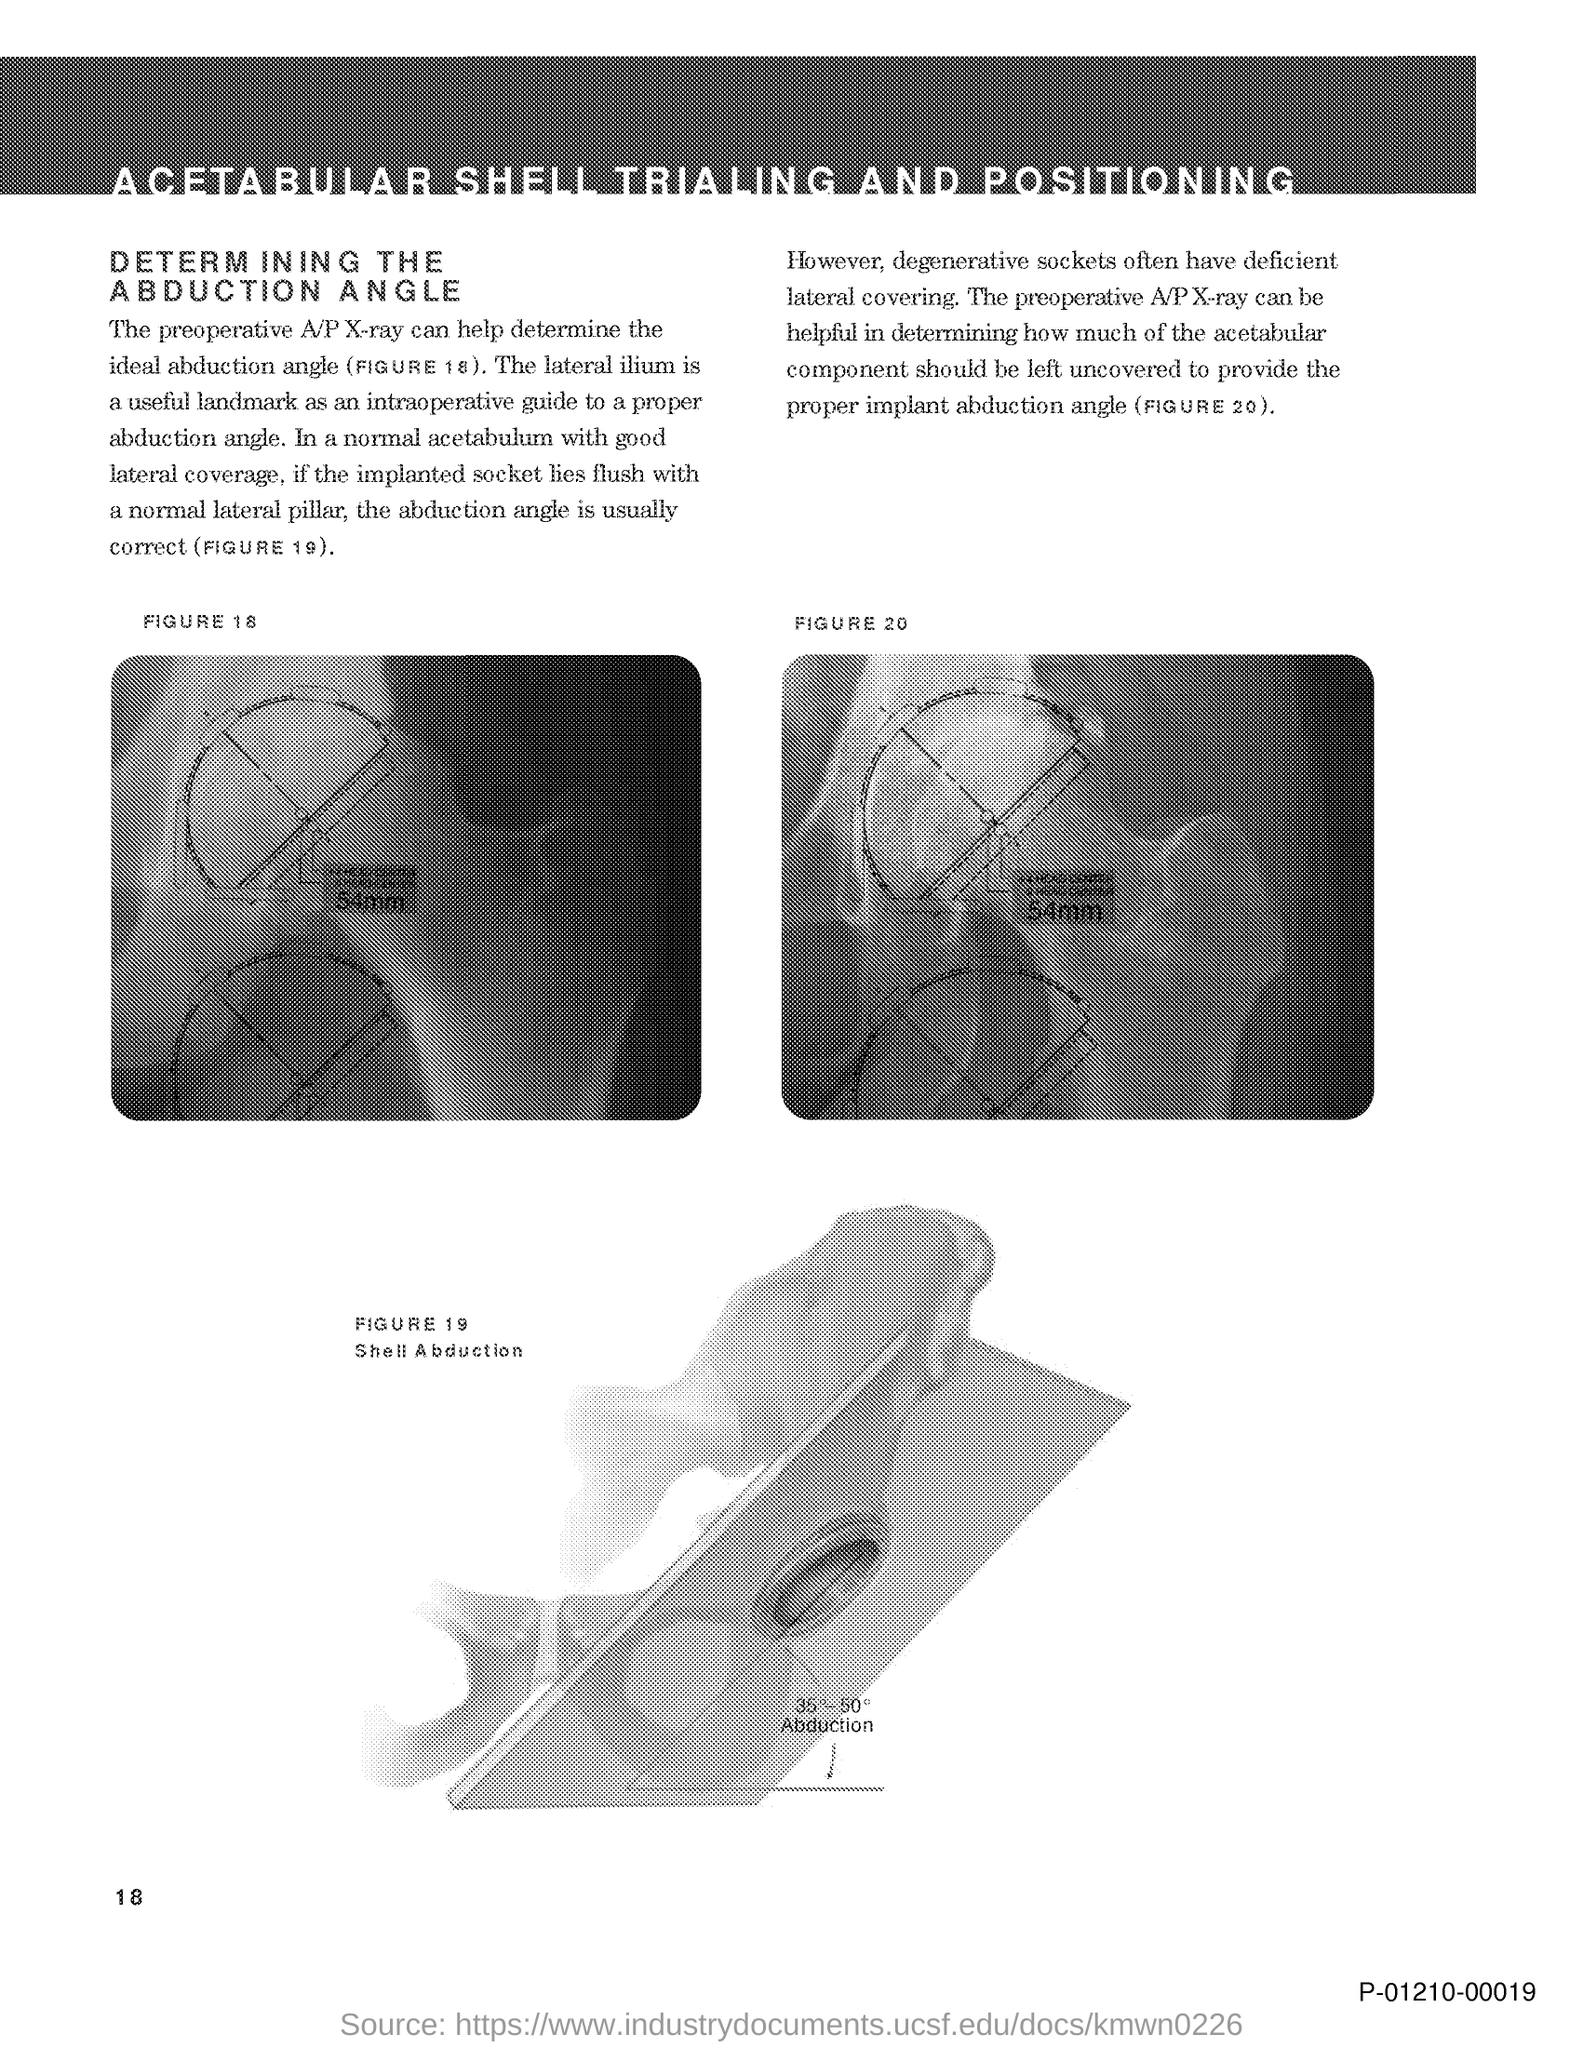Specify some key components in this picture. The page number mentioned in this document is 18. FIGURE 19 in this document represents shell abduction. In intraoperative procedures, a useful landmark for determining a proper abduction angle is the lateral ilium, which provides a reliable guide for achieving optimal alignment. The Preoperative A/P X-ray is the X-ray that can assist in determining the ideal abduction angle. 